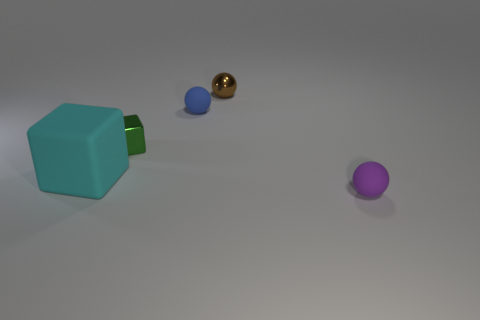Subtract all tiny rubber balls. How many balls are left? 1 Add 2 large blocks. How many objects exist? 7 Subtract all spheres. How many objects are left? 2 Subtract all brown objects. Subtract all brown things. How many objects are left? 3 Add 3 small metallic things. How many small metallic things are left? 5 Add 5 purple cubes. How many purple cubes exist? 5 Subtract 1 brown balls. How many objects are left? 4 